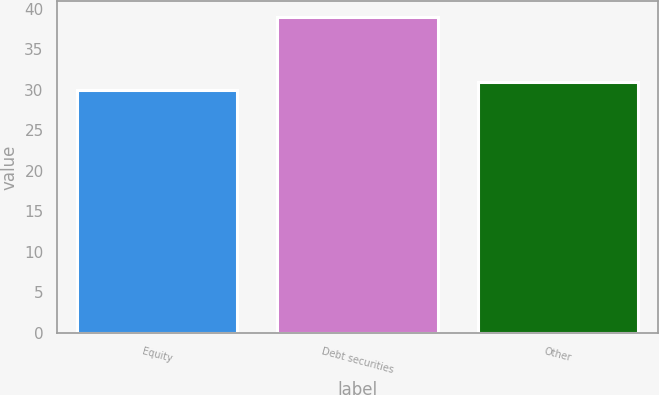<chart> <loc_0><loc_0><loc_500><loc_500><bar_chart><fcel>Equity<fcel>Debt securities<fcel>Other<nl><fcel>30<fcel>39<fcel>31<nl></chart> 